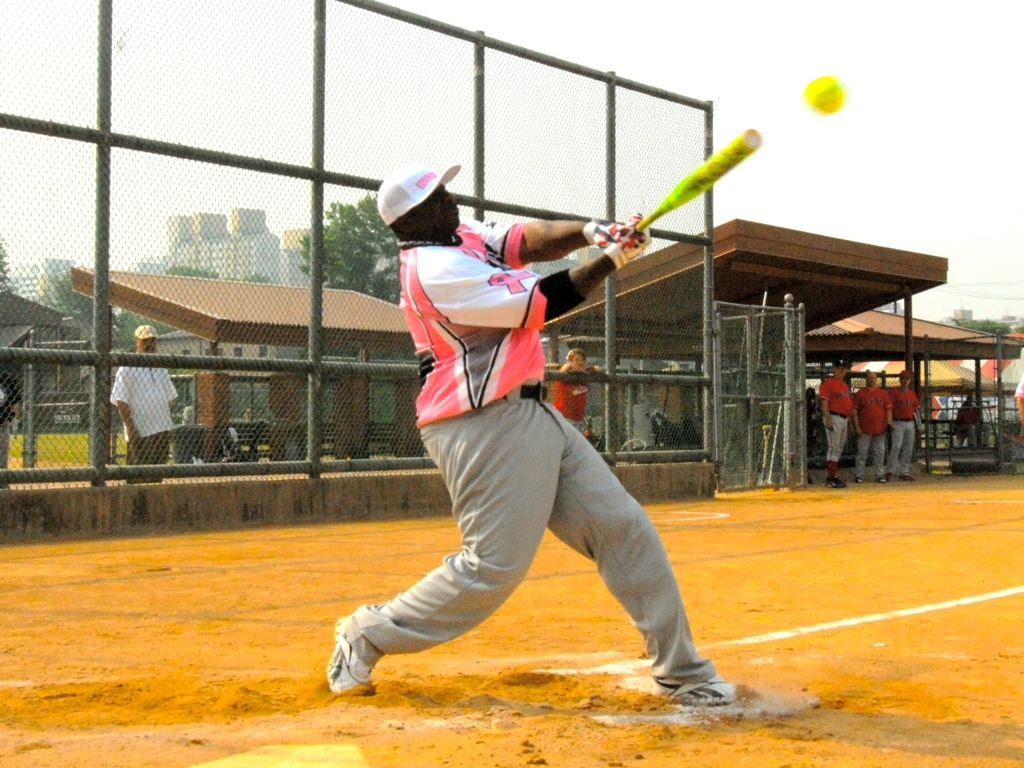What can we infer about the setting of this game? The game appears to be taking place on a typical dirt softball field, judging by the color and texture of the ground. There's a chain-link fence surrounding the field which is common in recreational sports areas. The presence of players and spectators in the background suggests a community or amateur-level match, rather than a professional setting. 